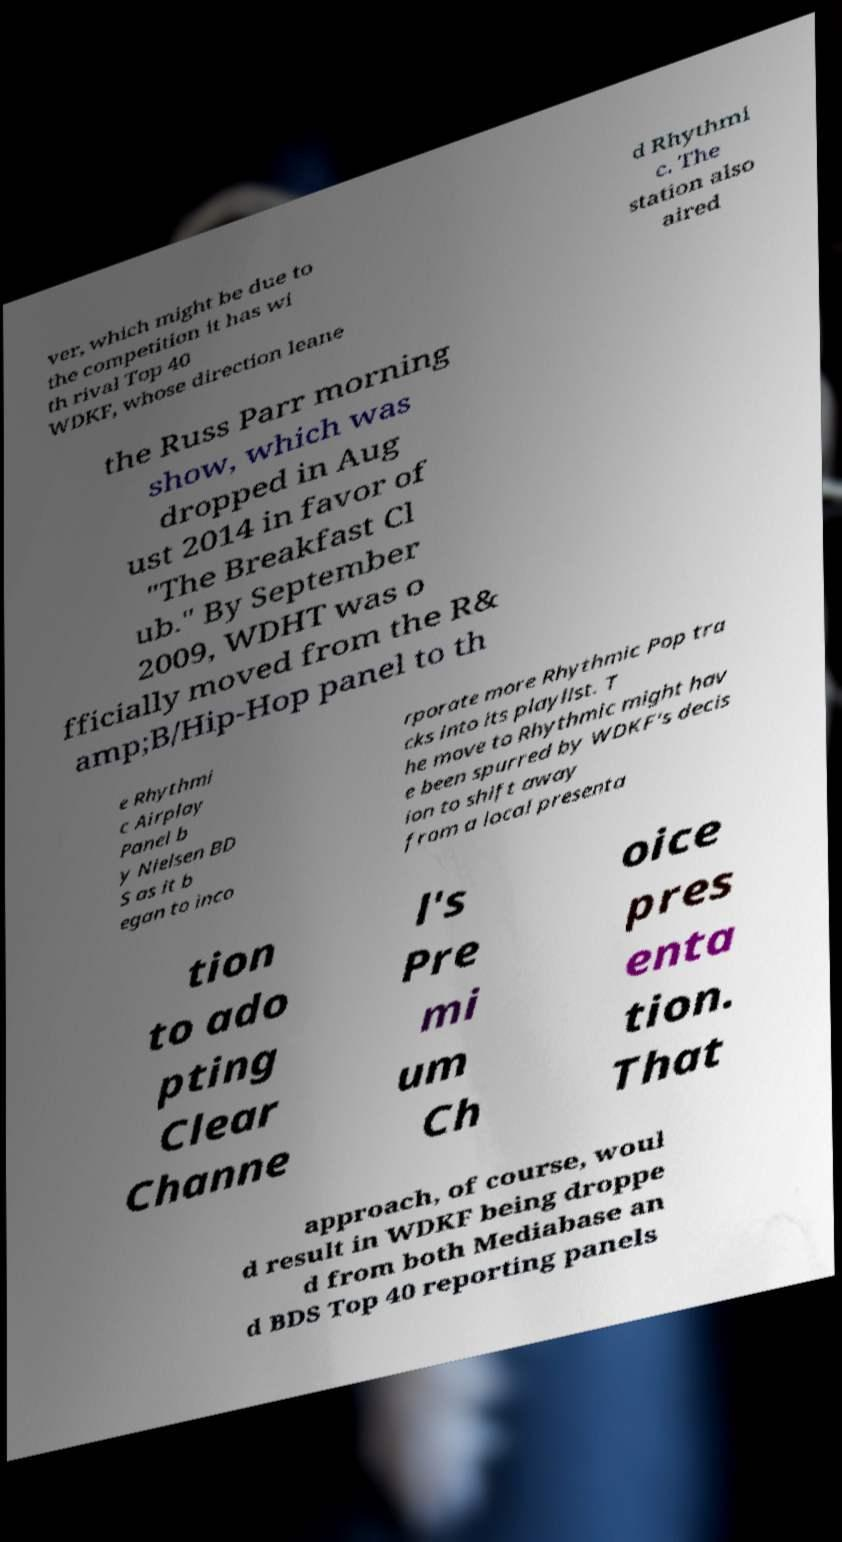Could you assist in decoding the text presented in this image and type it out clearly? ver, which might be due to the competition it has wi th rival Top 40 WDKF, whose direction leane d Rhythmi c. The station also aired the Russ Parr morning show, which was dropped in Aug ust 2014 in favor of "The Breakfast Cl ub." By September 2009, WDHT was o fficially moved from the R& amp;B/Hip-Hop panel to th e Rhythmi c Airplay Panel b y Nielsen BD S as it b egan to inco rporate more Rhythmic Pop tra cks into its playlist. T he move to Rhythmic might hav e been spurred by WDKF's decis ion to shift away from a local presenta tion to ado pting Clear Channe l's Pre mi um Ch oice pres enta tion. That approach, of course, woul d result in WDKF being droppe d from both Mediabase an d BDS Top 40 reporting panels 